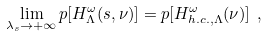<formula> <loc_0><loc_0><loc_500><loc_500>\lim _ { \lambda _ { s } \rightarrow + \infty } p [ H _ { \Lambda } ^ { \omega } ( s , \nu ) ] = p [ H _ { h . c . , \Lambda } ^ { \omega } ( \nu ) ] \ ,</formula> 